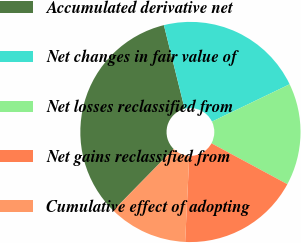Convert chart to OTSL. <chart><loc_0><loc_0><loc_500><loc_500><pie_chart><fcel>Accumulated derivative net<fcel>Net changes in fair value of<fcel>Net losses reclassified from<fcel>Net gains reclassified from<fcel>Cumulative effect of adopting<nl><fcel>33.77%<fcel>21.74%<fcel>15.0%<fcel>17.9%<fcel>11.59%<nl></chart> 